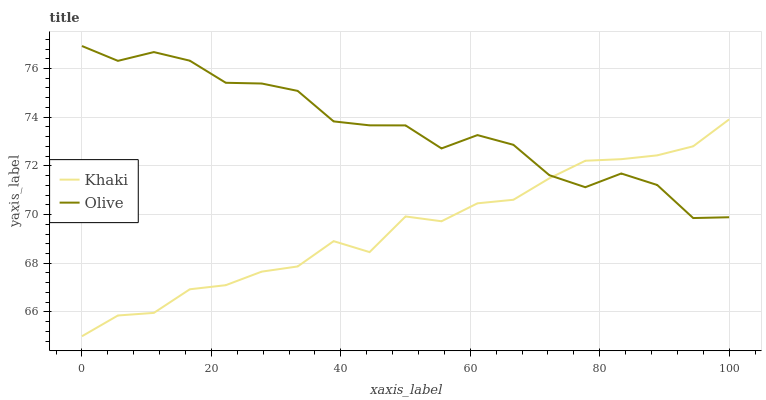Does Khaki have the minimum area under the curve?
Answer yes or no. Yes. Does Olive have the maximum area under the curve?
Answer yes or no. Yes. Does Khaki have the maximum area under the curve?
Answer yes or no. No. Is Khaki the smoothest?
Answer yes or no. Yes. Is Olive the roughest?
Answer yes or no. Yes. Is Khaki the roughest?
Answer yes or no. No. Does Khaki have the lowest value?
Answer yes or no. Yes. Does Olive have the highest value?
Answer yes or no. Yes. Does Khaki have the highest value?
Answer yes or no. No. Does Olive intersect Khaki?
Answer yes or no. Yes. Is Olive less than Khaki?
Answer yes or no. No. Is Olive greater than Khaki?
Answer yes or no. No. 